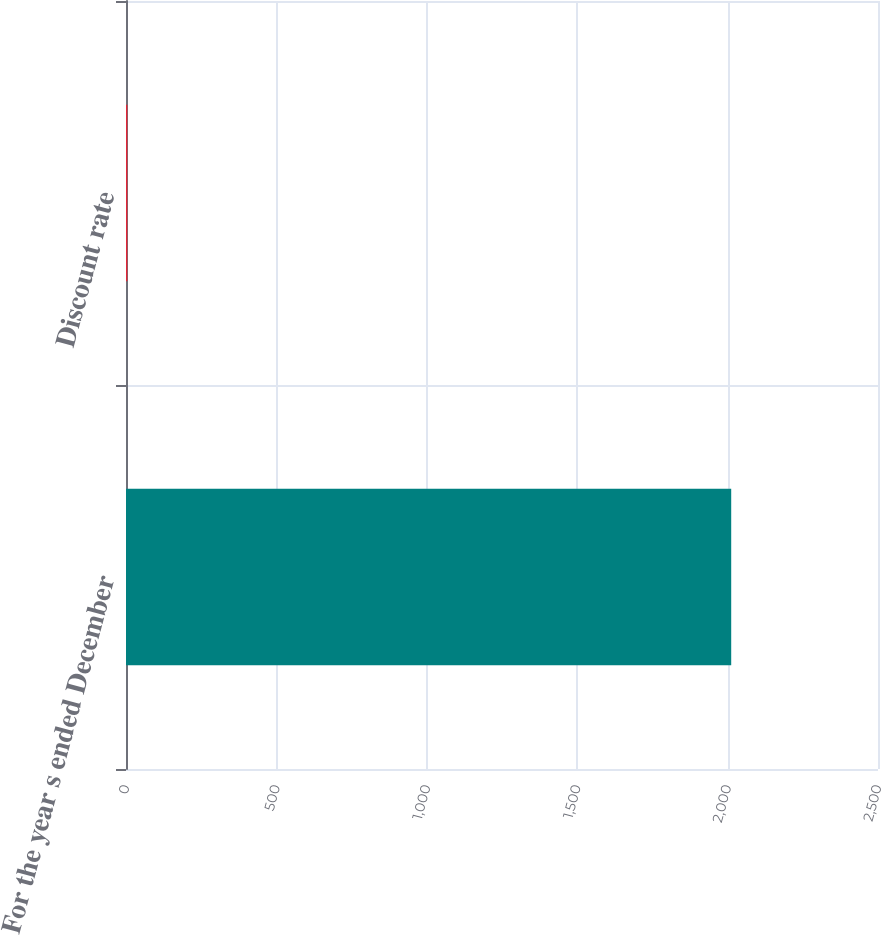Convert chart. <chart><loc_0><loc_0><loc_500><loc_500><bar_chart><fcel>For the year s ended December<fcel>Discount rate<nl><fcel>2012<fcel>4.5<nl></chart> 